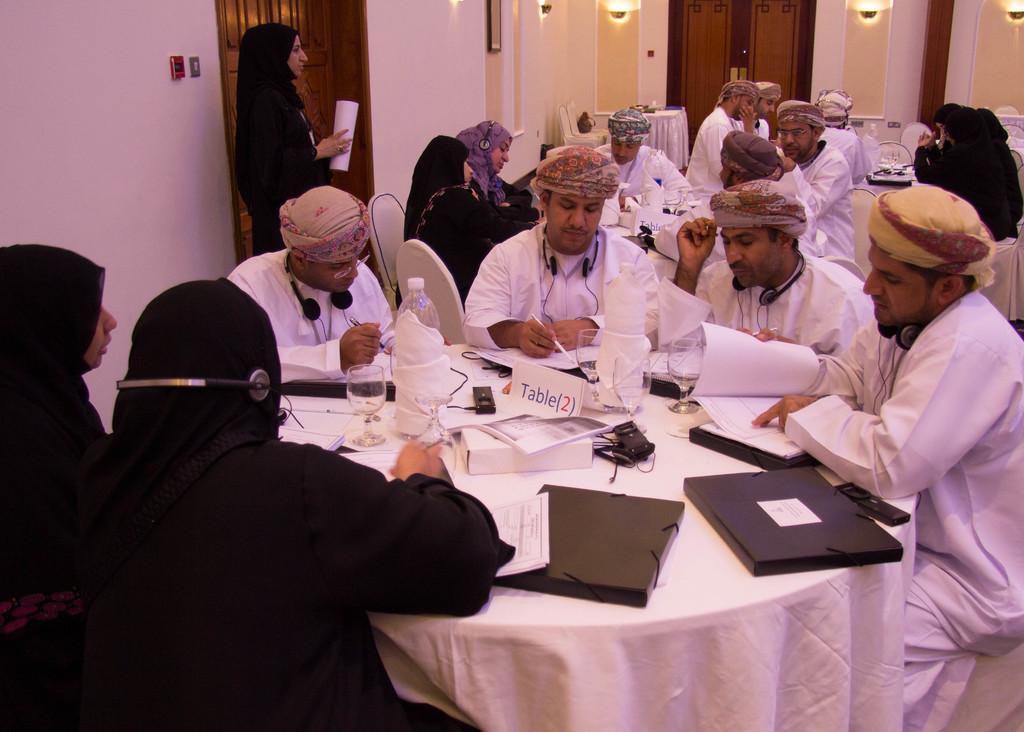Could you give a brief overview of what you see in this image? In a room this group of people are sitting on a chair. On every person head there is a headset. On this table there is a file, bottle, glass and papers. This woman is standing and holds a paper. This are doors. Lights are attached to wall. Man wore white dress. Woman's wore black dress. 